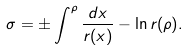Convert formula to latex. <formula><loc_0><loc_0><loc_500><loc_500>\sigma = \pm \int ^ { \rho } \frac { d x } { r ( x ) } - \ln r ( \rho ) .</formula> 